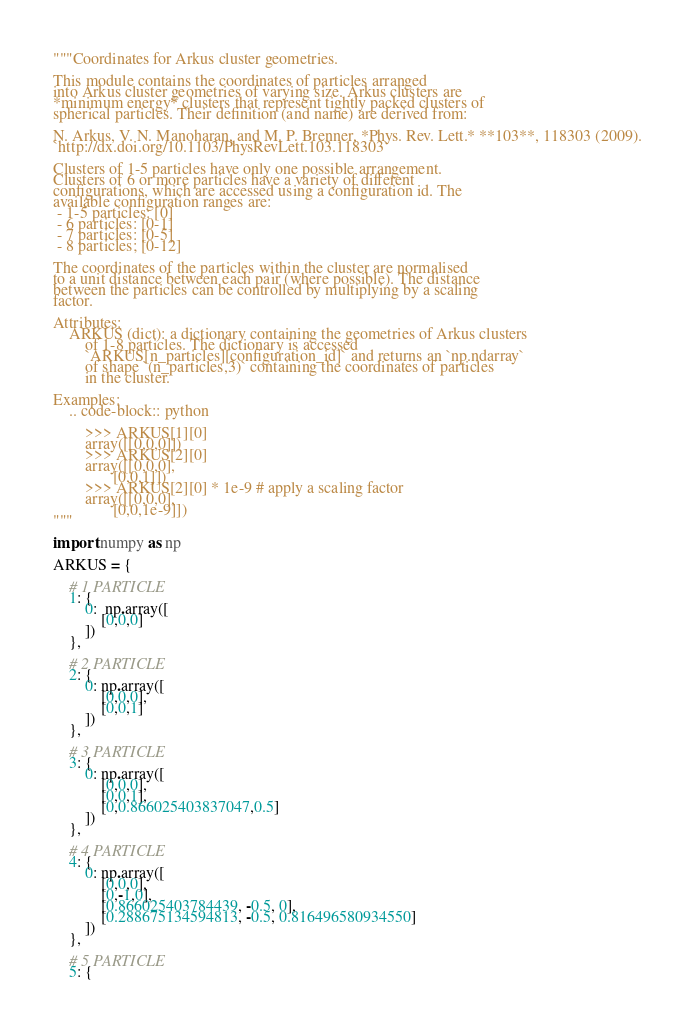<code> <loc_0><loc_0><loc_500><loc_500><_Python_>"""Coordinates for Arkus cluster geometries.

This module contains the coordinates of particles arranged
into Arkus cluster geometries of varying size. Arkus clusters are
*minimum energy* clusters that represent tightly packed clusters of
spherical particles. Their definition (and name) are derived from:

N. Arkus, V. N. Manoharan, and M. P. Brenner, *Phys. Rev. Lett.* **103**, 118303 (2009).
`http://dx.doi.org/10.1103/PhysRevLett.103.118303`

Clusters of 1-5 particles have only one possible arrangement.
Clusters of 6 or more particles have a variety of different
configurations, which are accessed using a configuration id. The
available configuration ranges are:
 - 1-5 particles: [0]
 - 6 particles: [0-1]
 - 7 particles: [0-5]
 - 8 particles; [0-12]

The coordinates of the particles within the cluster are normalised
to a unit distance between each pair (where possible). The distance
between the particles can be controlled by multiplying by a scaling
factor.

Attributes:
    ARKUS (dict): a dictionary containing the geometries of Arkus clusters
        of 1-8 particles. The dictionary is accessed
        `ARKUS[n_particles][configuration_id]` and returns an `np.ndarray`
        of shape `(n_particles,3)` containing the coordinates of particles
        in the cluster.

Examples:
    .. code-block:: python

        >>> ARKUS[1][0]
        array([[0,0,0]])
        >>> ARKUS[2][0]
        array([[0,0,0],
               [0,0,1]])
        >>> ARKUS[2][0] * 1e-9 # apply a scaling factor
        array([[0,0,0],
               [0,0,1e-9]])
"""

import numpy as np

ARKUS = {

    # 1 PARTICLE
    1: {
        0:  np.array([
            [0,0,0]
        ])
    },

    # 2 PARTICLE
    2: {
        0: np.array([
            [0,0,0],
            [0,0,1]
        ])
    },

    # 3 PARTICLE
    3: {
        0: np.array([
            [0,0,0],
            [0,0,1],
            [0,0.866025403837047,0.5]
        ])
    },

    # 4 PARTICLE
    4: {
        0: np.array([
            [0,0,0],
            [0,-1,0],
            [0.866025403784439, -0.5, 0],
            [0.288675134594813, -0.5, 0.816496580934550]
        ])
    },

    # 5 PARTICLE
    5: {</code> 